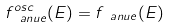Convert formula to latex. <formula><loc_0><loc_0><loc_500><loc_500>f _ { \ a n u e } ^ { o s c } ( E ) = f _ { \ a n u e } ( E )</formula> 